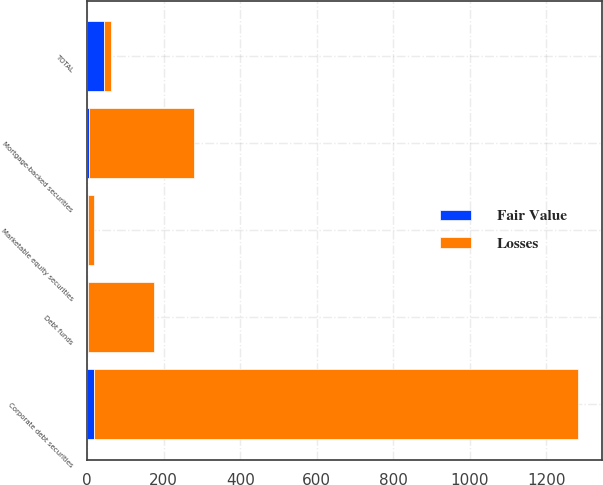Convert chart to OTSL. <chart><loc_0><loc_0><loc_500><loc_500><stacked_bar_chart><ecel><fcel>Corporate debt securities<fcel>Mortgage-backed securities<fcel>Debt funds<fcel>Marketable equity securities<fcel>TOTAL<nl><fcel>Losses<fcel>1263<fcel>276<fcel>173<fcel>14<fcel>19<nl><fcel>Fair Value<fcel>19<fcel>4<fcel>1<fcel>3<fcel>43<nl></chart> 